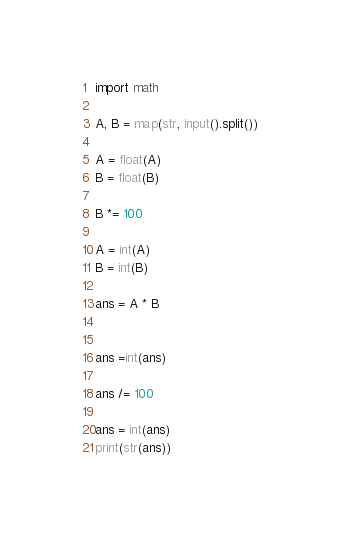<code> <loc_0><loc_0><loc_500><loc_500><_Python_>import math

A, B = map(str, input().split())

A = float(A)
B = float(B)

B *= 100

A = int(A)
B = int(B)

ans = A * B


ans =int(ans)

ans /= 100

ans = int(ans)
print(str(ans))
</code> 